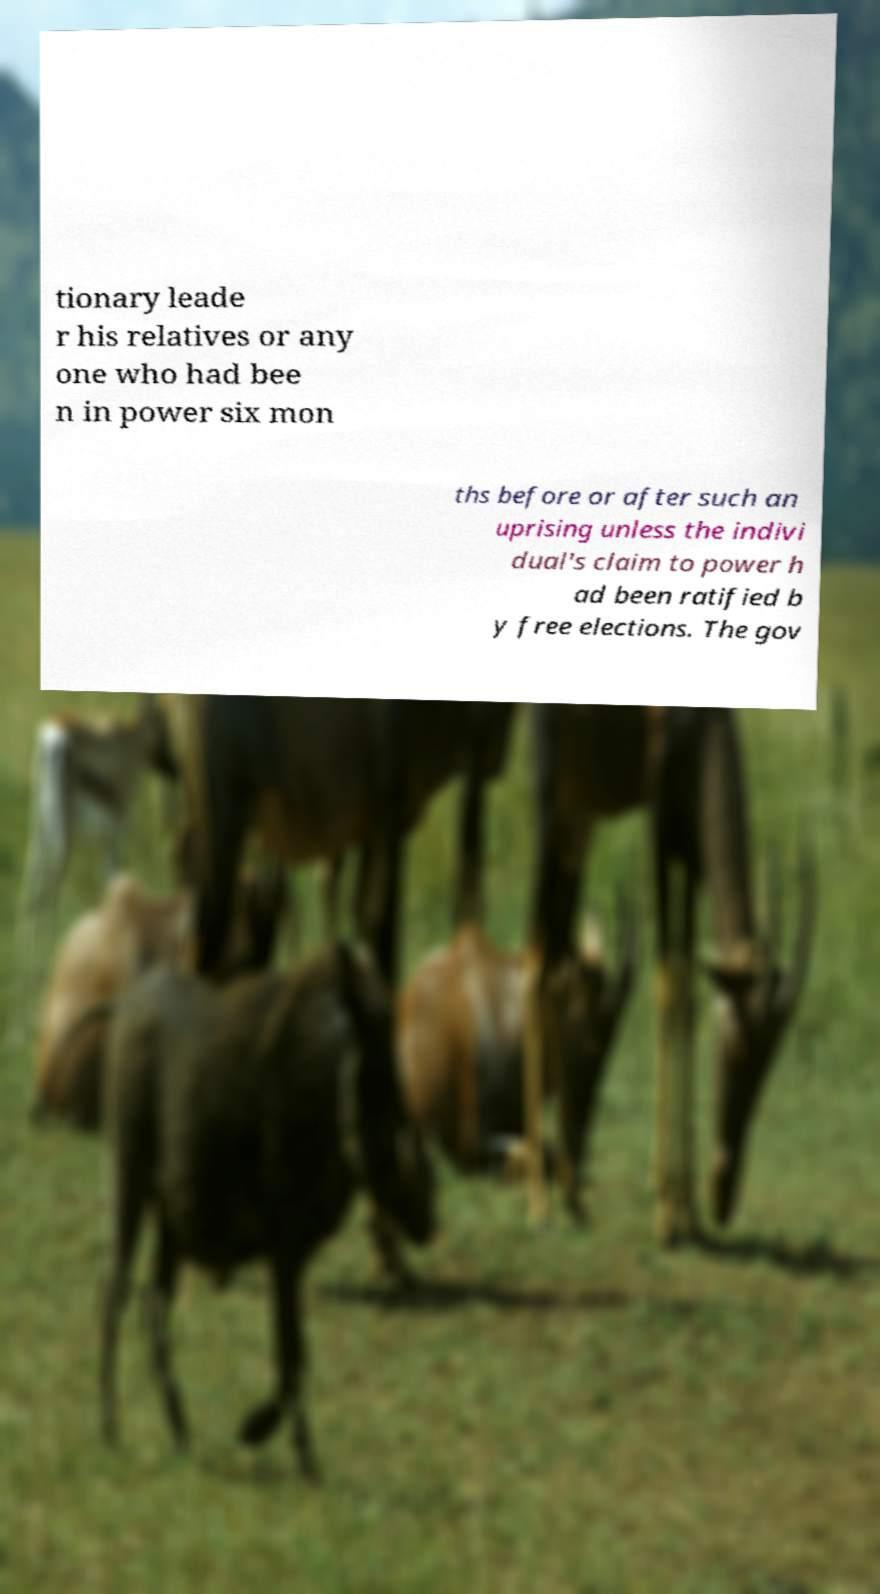Can you read and provide the text displayed in the image?This photo seems to have some interesting text. Can you extract and type it out for me? tionary leade r his relatives or any one who had bee n in power six mon ths before or after such an uprising unless the indivi dual's claim to power h ad been ratified b y free elections. The gov 